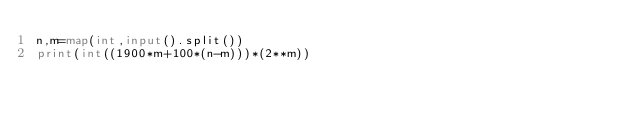<code> <loc_0><loc_0><loc_500><loc_500><_Python_>n,m=map(int,input().split())
print(int((1900*m+100*(n-m)))*(2**m))
</code> 